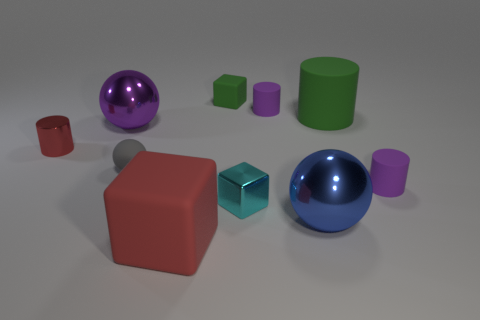What number of things are either large cubes or large blue things?
Your response must be concise. 2. What is the size of the cylinder that is both in front of the large purple metallic thing and to the right of the blue shiny object?
Offer a very short reply. Small. Is the number of cylinders that are right of the blue sphere less than the number of large blue shiny balls?
Ensure brevity in your answer.  No. There is a gray thing that is the same material as the large green cylinder; what is its shape?
Offer a terse response. Sphere. Do the large rubber thing behind the big purple sphere and the purple rubber object that is in front of the big green matte thing have the same shape?
Give a very brief answer. Yes. Is the number of red matte things that are right of the large green matte thing less than the number of tiny gray matte things to the right of the small ball?
Your response must be concise. No. There is a small metallic thing that is the same color as the large cube; what shape is it?
Provide a short and direct response. Cylinder. How many blue shiny things have the same size as the red cylinder?
Your answer should be compact. 0. Is the block that is in front of the small cyan shiny cube made of the same material as the small green cube?
Provide a short and direct response. Yes. Are any gray things visible?
Your answer should be compact. Yes. 